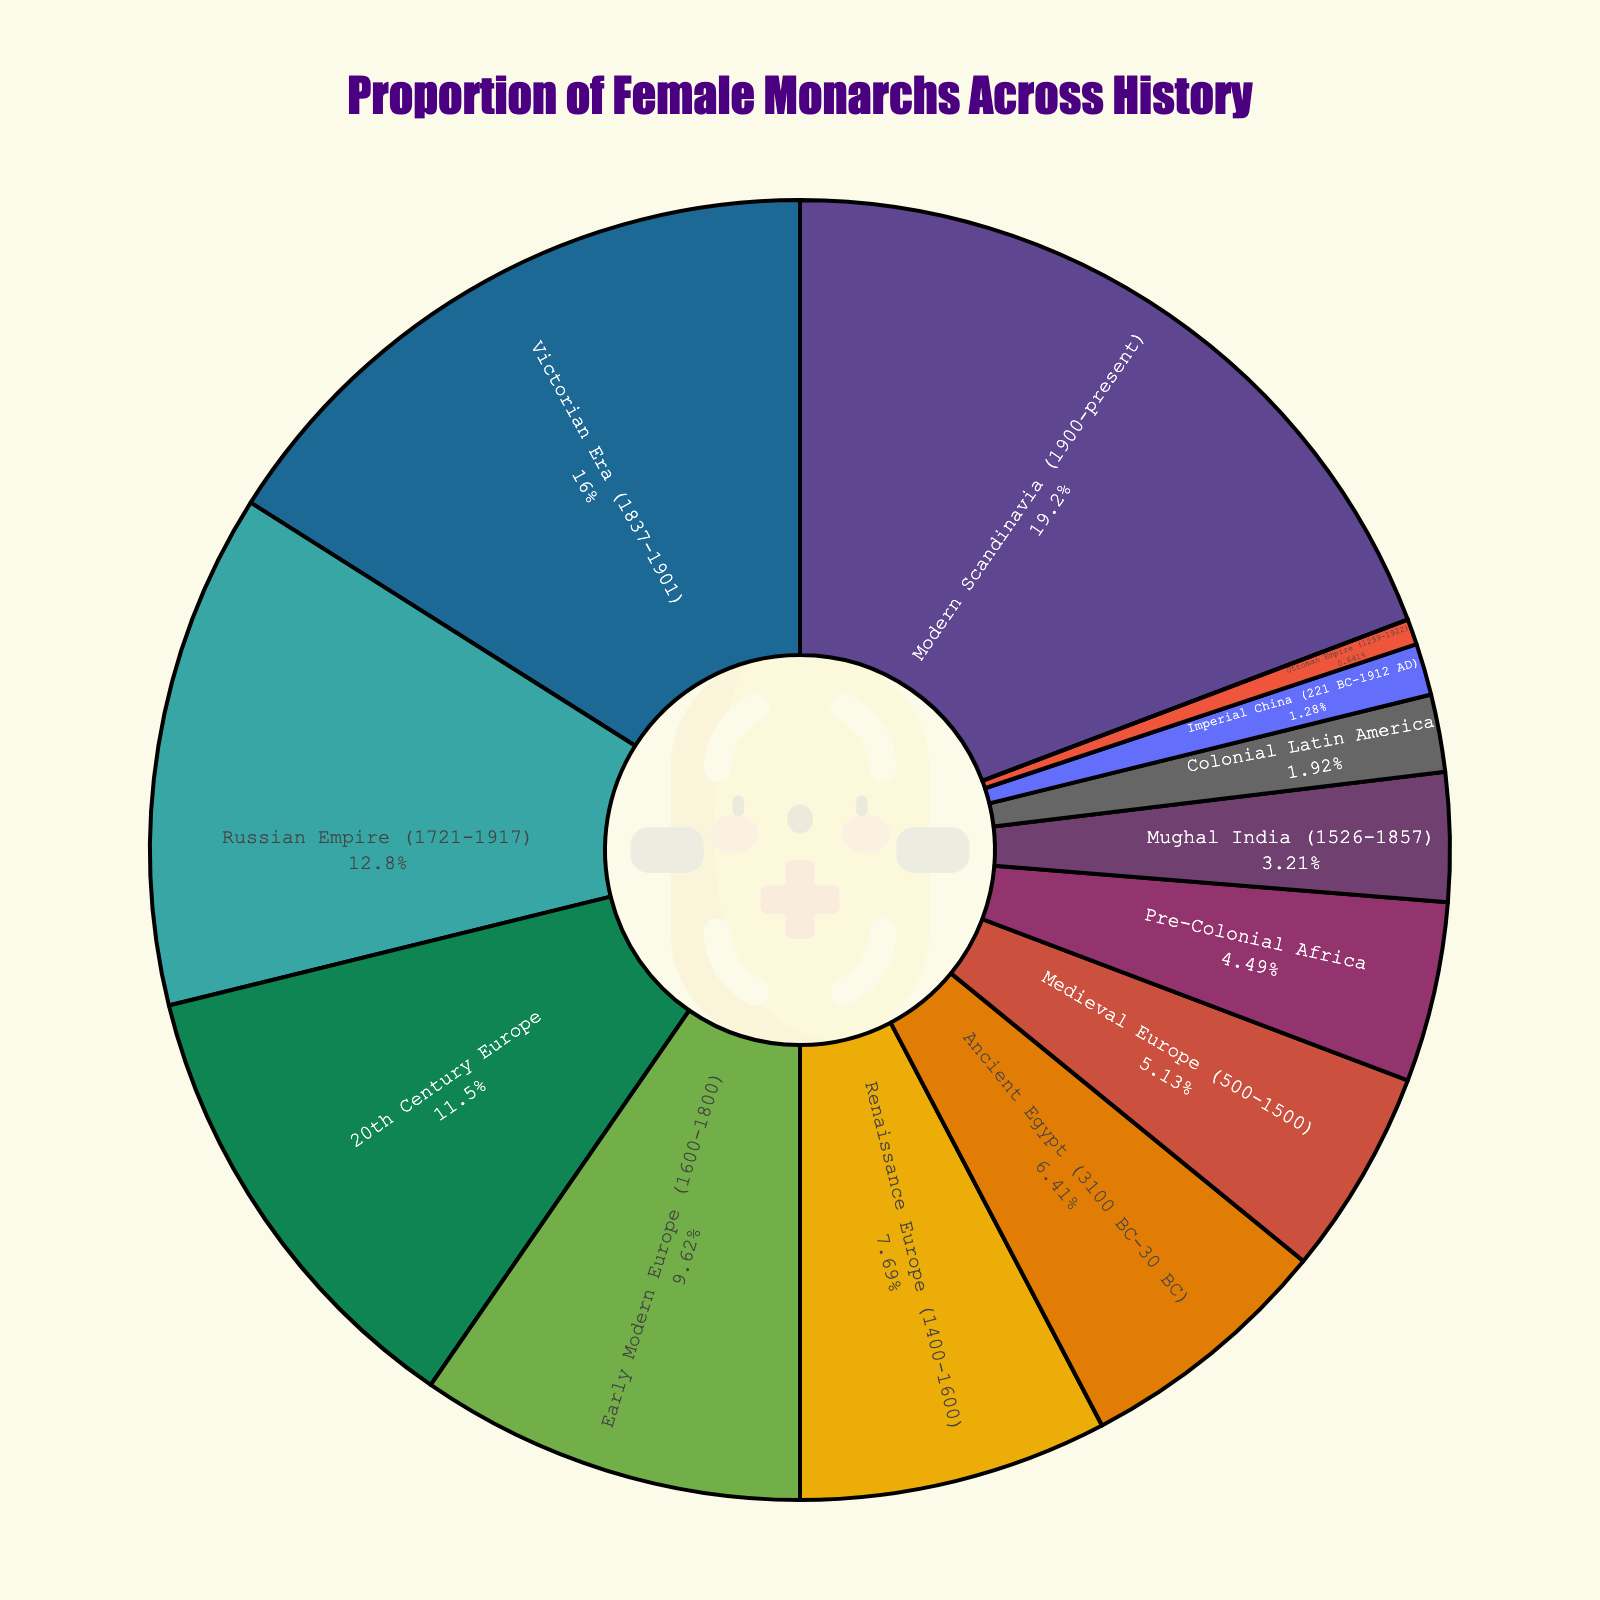What's the period/region with the highest proportion of female monarchs? The figure shows a pie chart where each segment represents a different period/region with its respective percentage of female monarchs. The segment with the highest percentage is labeled "Modern Scandinavia (1900-present)" with 30%.
Answer: Modern Scandinavia (1900-present) Compare the proportion of female monarchs in the Medieval Europe and Victorian Era. Which is higher and by how much? The figure shows "Medieval Europe (500-1500)" with 8% and "Victorian Era (1837-1901)" with 25%. The difference is calculated by subtracting 8% from 25%, which results in 17%.
Answer: Victorian Era, by 17% What is the combined percentage of female monarchs in Renaissance Europe and Early Modern Europe? Renaissance Europe has 12% and Early Modern Europe has 15%. Adding these percentages together, we get 12% + 15% = 27%.
Answer: 27% Which region has a proportion of female monarchs equal to 0%? Looking at the segments of the pie chart, the one labeled "Tokugawa Japan (1603-1868)" shows an equal percentage of 0%.
Answer: Tokugawa Japan How does the percentage of female monarchs in the Russian Empire compare to that in the Mughal India? The figure shows "Russian Empire (1721-1917)" with 20% and "Mughal India (1526-1857)" with 5%. Comparing them, the Russian Empire has a higher percentage by 15%.
Answer: Russian Empire, by 15% Which period/region is represented by a segment with a 10% proportion of female monarchs and what color is it? The pie chart segment labeled "Ancient Egypt (3100 BC-30 BC)" is associated with a 10% proportion of female monarchs. The color of this segment can be identified visually from the chart.
Answer: Ancient Egypt, (color varies) What is the total percentage of female monarchs in regions with single-digit proportions? Adding percentages from periods/regions with single-digit values: Medieval Europe (8%), Imperial China (2%), Tokugawa Japan (0%), Mughal India (5%), Ottoman Empire (1%), Pre-Colonial Africa (7%), Colonial Latin America (3%). The total is 8% + 2% + 0% + 5% + 1% + 7% + 3% = 26%.
Answer: 26% Which two regions have the closest percentages of female monarchs and what are these percentages? Looking at the pie chart, "20th Century Europe" has 18% and "Ancient Egypt" has 10%. The closest percentages are Ancient Egypt (10%) and Pre-Colonial Africa (7%) with a difference of 3%.
Answer: Ancient Egypt and Pre-Colonial Africa, 10% and 7% If you combine the percentages of female monarchs in 20th Century Europe and Modern Scandinavia, how much is that combined percentage? The figure shows "20th Century Europe" with 18% and "Modern Scandinavia (1900-present)" with 30%. Adding these percentages together, we get 18% + 30% = 48%.
Answer: 48% Compare the proportion of female monarchs in the Ottoman Empire and Colonial Latin America. What is the difference in percentage points? The figure shows "Ottoman Empire (1299-1922)" with 1% and "Colonial Latin America" with 3%. The difference is calculated by subtracting 1% from 3%, which results in 2%.
Answer: 2% 